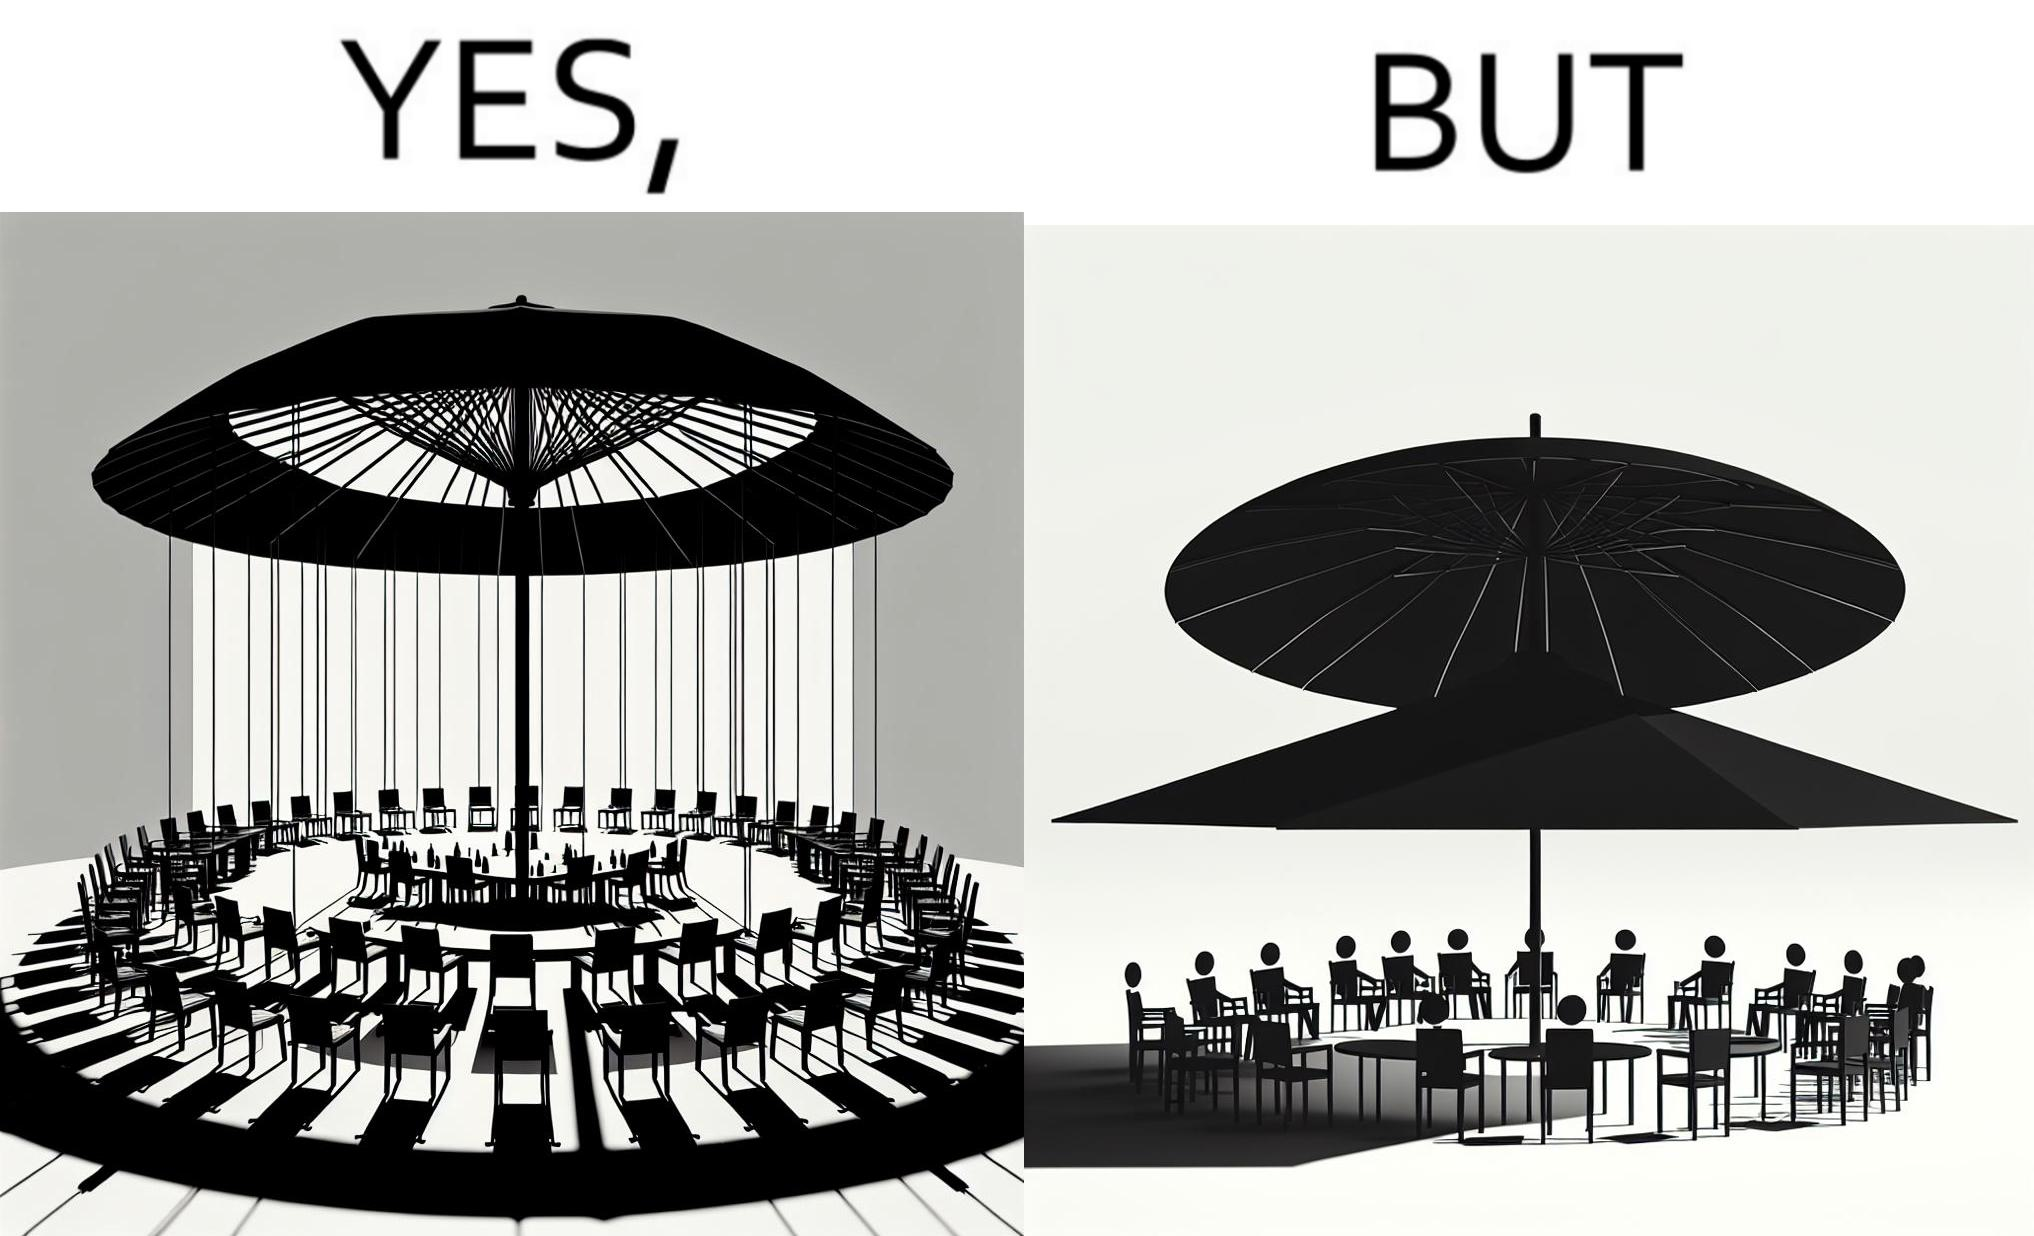Describe the contrast between the left and right parts of this image. In the left part of the image: Chairs surrounding a table under a large umbrella. In the right part of the image: Chairs surrounding a table under a large umbrella, with the shadow of the umbrella appearing on the side. 